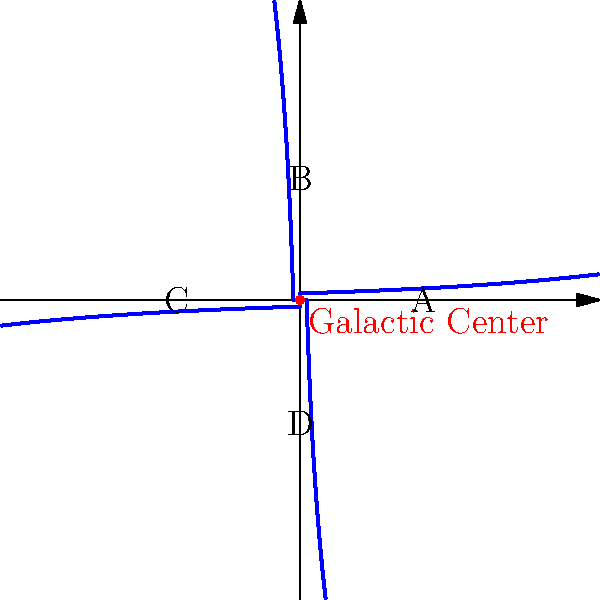As a city council member tasked with educating the community on various topics, including astronomy, you're preparing a presentation on the structure of the Milky Way galaxy. Using the spiral diagram provided, which represents a top-down view of our galaxy, which arm (labeled A, B, C, or D) is likely to contain the youngest stars and most active star-forming regions? To answer this question, we need to understand the structure and dynamics of spiral galaxies like the Milky Way:

1. Spiral galaxies rotate, with the outer regions moving more slowly than the inner regions. This differential rotation creates the spiral structure.

2. The spiral arms are regions of higher density, where gas and dust are compressed, triggering star formation.

3. New stars form in the leading edge of the spiral arms, where the compression is strongest.

4. As the galaxy rotates, these newly formed stars move through and eventually out of the spiral arm.

5. In the diagram, the galaxy is rotating clockwise (assuming the conventional view with north at the top).

6. The leading edge of each spiral arm is the outer edge, facing the direction of rotation.

7. Among the labeled points, A is on the leading edge of its spiral arm.

8. Therefore, the region around point A is likely to contain the youngest stars and most active star-forming regions.

This understanding of galactic structure helps us appreciate the dynamic nature of our galaxy and the ongoing processes of star formation, which are crucial for the evolution of the universe.
Answer: A 